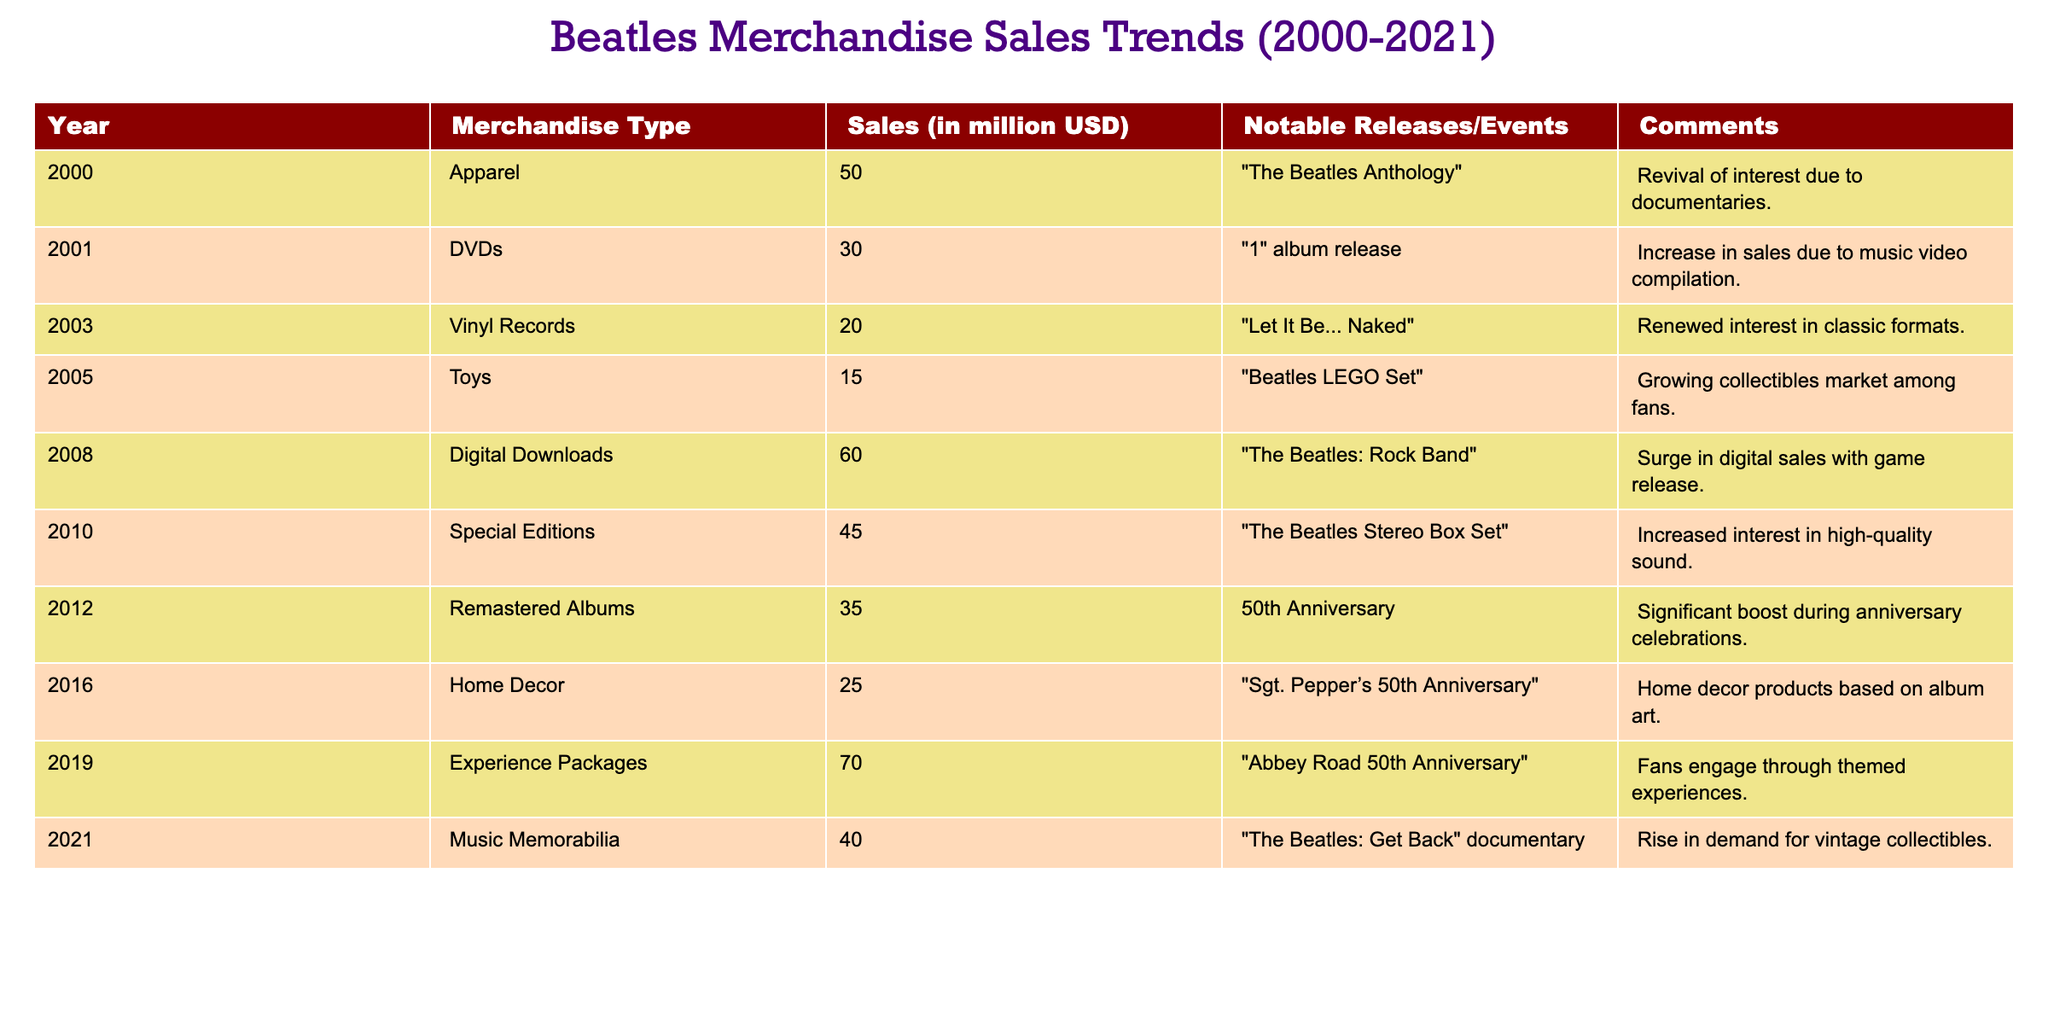What was the total sales amount for Digital Downloads and Experience Packages in 2021? To find the total sales amount, I add the sales figures for Digital Downloads (60 million USD) and Experience Packages (70 million USD). Therefore, the total is 60 + 70 = 130 million USD.
Answer: 130 million USD Which merchandise type had the highest sales in 2019? In 2019, the merchandise type with the highest sales was Experience Packages with 70 million USD.
Answer: Experience Packages True or False: The sales for Special Editions in 2010 exceeded those of Home Decor in 2016. The sales for Special Editions in 2010 were 45 million USD, and Home Decor in 2016 were 25 million USD. Since 45 is greater than 25, the statement is true.
Answer: True What was the trend in sales for Vinyl Records between 2003 and 2008? In 2003, Vinyl Records had sales of 20 million USD, and by 2008, sales surged to 60 million USD. This indicates a significant increase in sales over these years.
Answer: The sales trend increased How much did the sales of Toys in 2005 and Home Decor in 2016 combined? To find the combined sales, I add the sales for Toys (15 million USD) in 2005 and Home Decor (25 million USD) in 2016. So, the total sales are 15 + 25 = 40 million USD.
Answer: 40 million USD Which year reported a notable event related to "The Beatles: Get Back" documentary? The year 2021 is when the documentary "The Beatles: Get Back" was released, coinciding with a rise in demand for music memorabilia with sales of 40 million USD.
Answer: 2021 What was the average sales of merchandise types in 2000 and 2001? In 2000, sales were 50 million USD for Apparel, and in 2001 sales were 30 million USD for DVDs. To find the average, I add both sales and divide by 2: (50 + 30) / 2 = 40 million USD.
Answer: 40 million USD Did the release of "The Beatles: Rock Band" in 2008 have an impact on digital downloads sales? Yes, in 2008, digital downloads sales surged to 60 million USD following the release of "The Beatles: Rock Band," indicating a positive impact.
Answer: Yes 